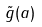<formula> <loc_0><loc_0><loc_500><loc_500>\tilde { g } ( a )</formula> 